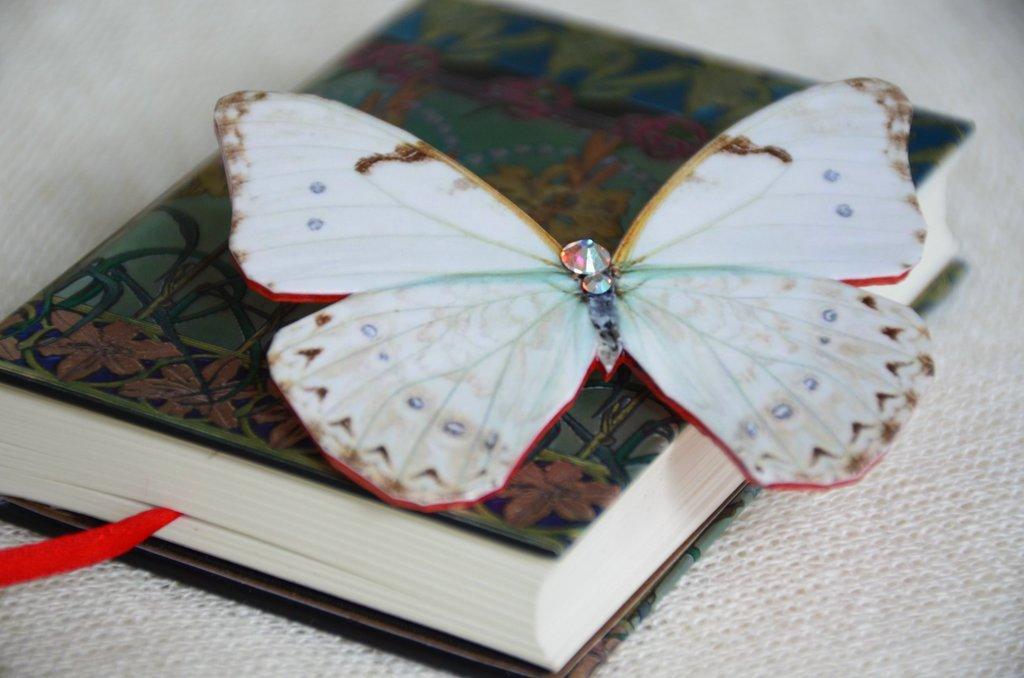How would you summarize this image in a sentence or two? In this picture we can see a book with a sticker butterfly on it and this book is placed on a cloth. 